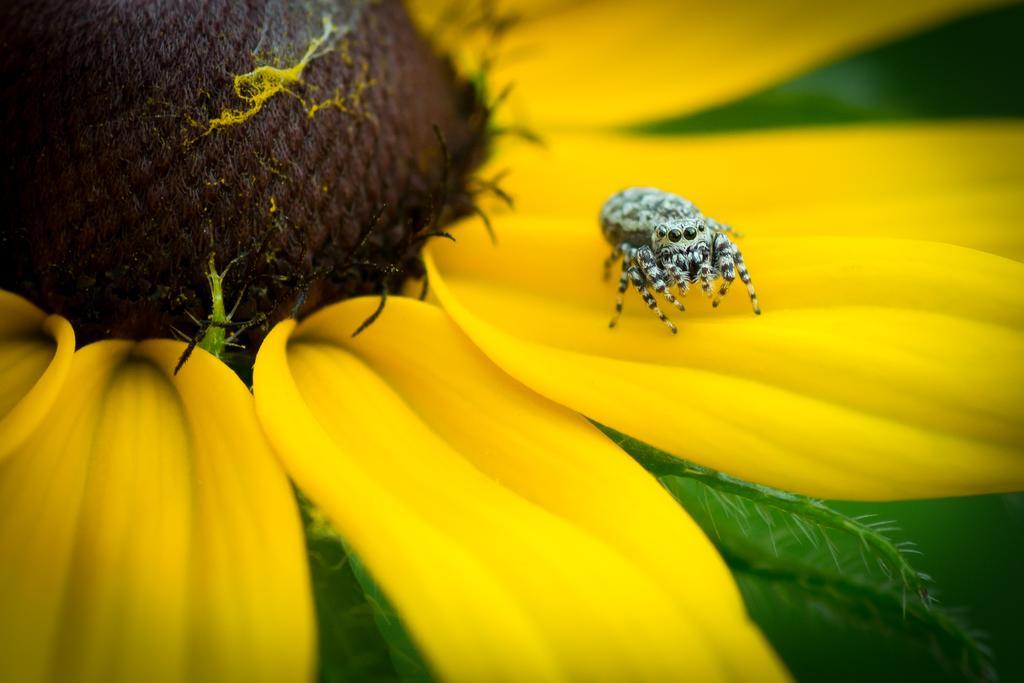Could you give a brief overview of what you see in this image? In this image we can see an insect on the petal of a flower. 